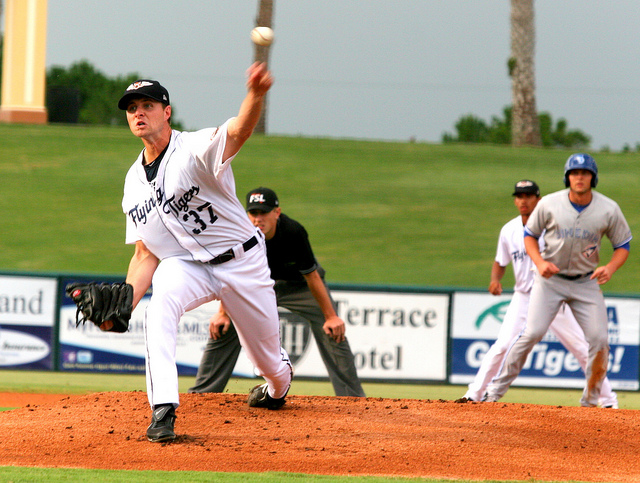Please identify all text content in this image. 37 Tiger Flying errace otel H FSL and 